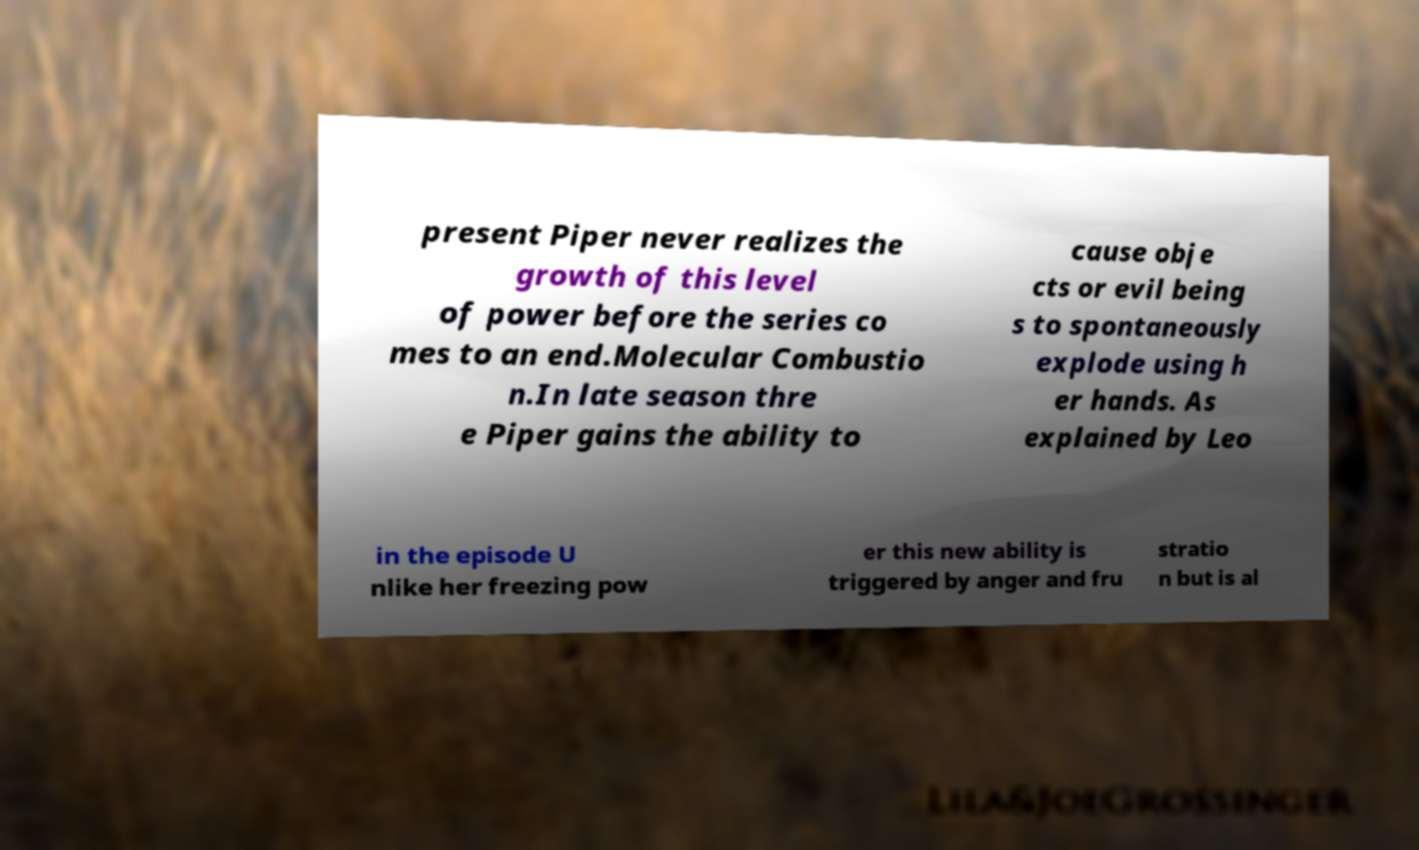There's text embedded in this image that I need extracted. Can you transcribe it verbatim? present Piper never realizes the growth of this level of power before the series co mes to an end.Molecular Combustio n.In late season thre e Piper gains the ability to cause obje cts or evil being s to spontaneously explode using h er hands. As explained by Leo in the episode U nlike her freezing pow er this new ability is triggered by anger and fru stratio n but is al 